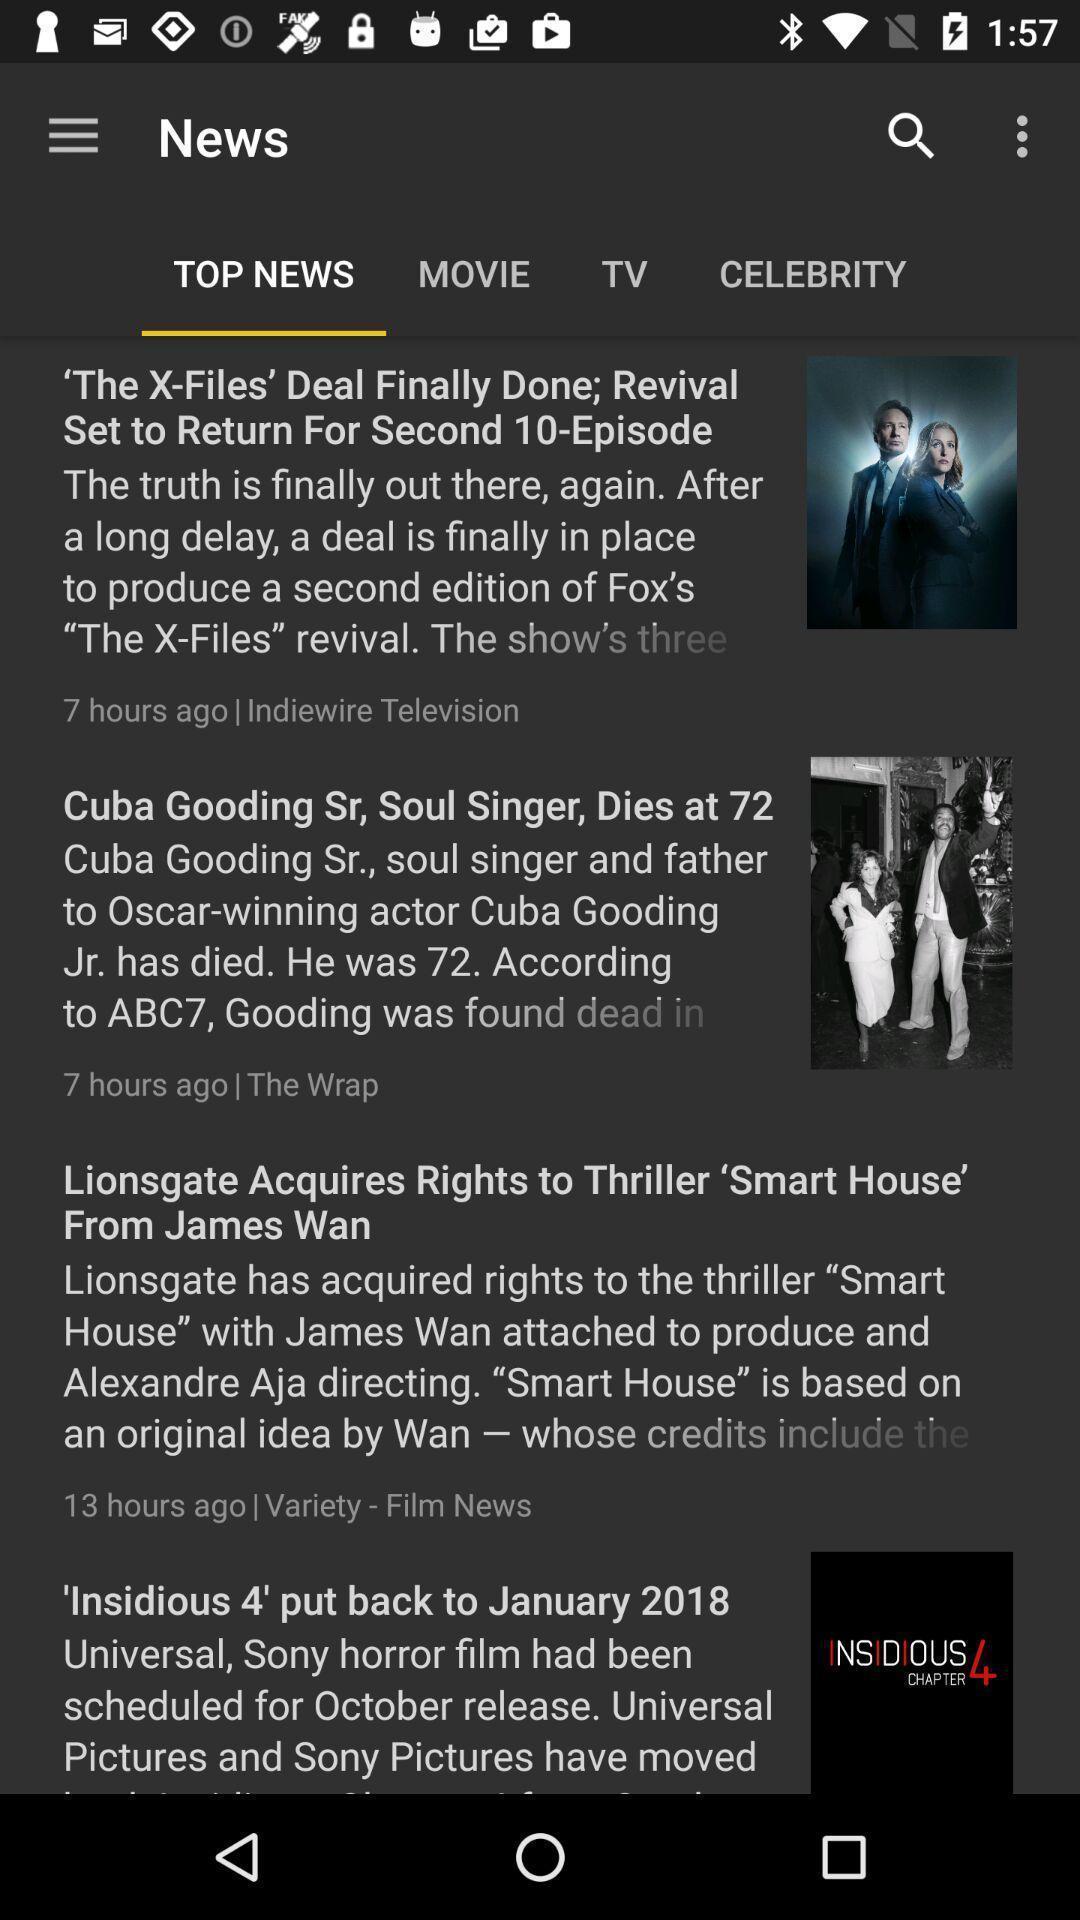Provide a textual representation of this image. Page showing top news. 